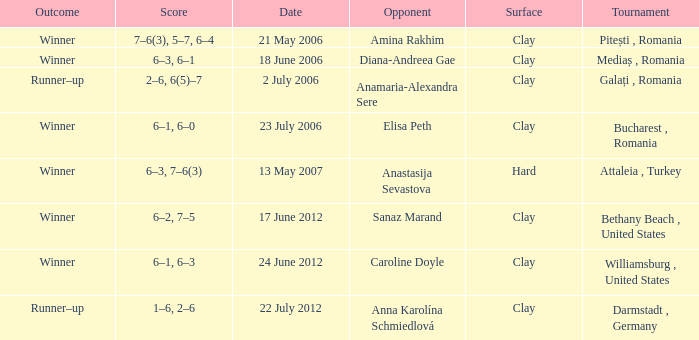Parse the table in full. {'header': ['Outcome', 'Score', 'Date', 'Opponent', 'Surface', 'Tournament'], 'rows': [['Winner', '7–6(3), 5–7, 6–4', '21 May 2006', 'Amina Rakhim', 'Clay', 'Pitești , Romania'], ['Winner', '6–3, 6–1', '18 June 2006', 'Diana-Andreea Gae', 'Clay', 'Mediaș , Romania'], ['Runner–up', '2–6, 6(5)–7', '2 July 2006', 'Anamaria-Alexandra Sere', 'Clay', 'Galați , Romania'], ['Winner', '6–1, 6–0', '23 July 2006', 'Elisa Peth', 'Clay', 'Bucharest , Romania'], ['Winner', '6–3, 7–6(3)', '13 May 2007', 'Anastasija Sevastova', 'Hard', 'Attaleia , Turkey'], ['Winner', '6–2, 7–5', '17 June 2012', 'Sanaz Marand', 'Clay', 'Bethany Beach , United States'], ['Winner', '6–1, 6–3', '24 June 2012', 'Caroline Doyle', 'Clay', 'Williamsburg , United States'], ['Runner–up', '1–6, 2–6', '22 July 2012', 'Anna Karolína Schmiedlová', 'Clay', 'Darmstadt , Germany']]} What was the score in the match against Sanaz Marand? 6–2, 7–5. 